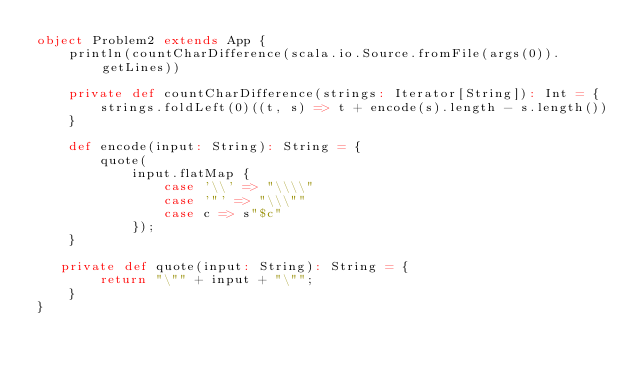<code> <loc_0><loc_0><loc_500><loc_500><_Scala_>object Problem2 extends App {
    println(countCharDifference(scala.io.Source.fromFile(args(0)).getLines))

    private def countCharDifference(strings: Iterator[String]): Int = {
        strings.foldLeft(0)((t, s) => t + encode(s).length - s.length())
    }

    def encode(input: String): String = {
        quote(
            input.flatMap {
                case '\\' => "\\\\"
                case '"' => "\\\""
                case c => s"$c"
            });
    }

   private def quote(input: String): String = {
        return "\"" + input + "\"";
    }
}</code> 